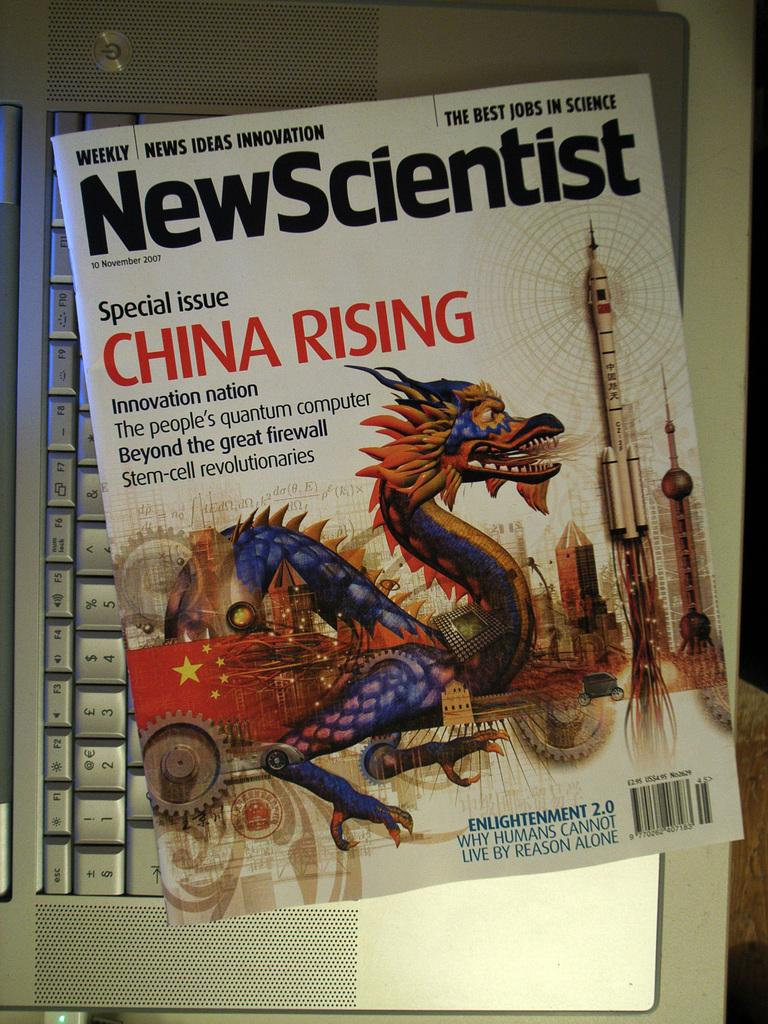<image>
Write a terse but informative summary of the picture. A magazine cover for new scientist wit hthe special issue title china rising. 